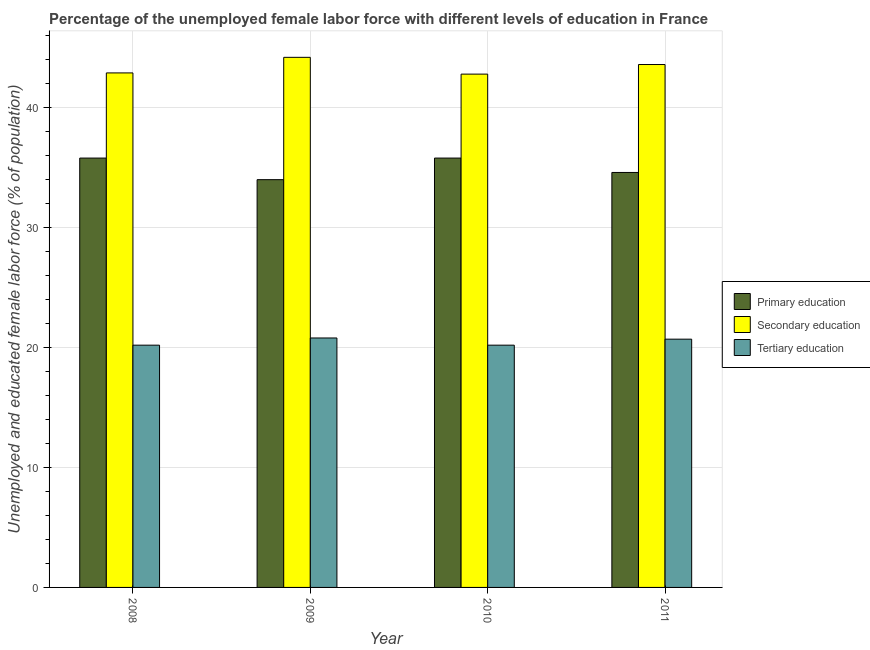How many groups of bars are there?
Keep it short and to the point. 4. Are the number of bars on each tick of the X-axis equal?
Give a very brief answer. Yes. How many bars are there on the 3rd tick from the left?
Provide a succinct answer. 3. How many bars are there on the 3rd tick from the right?
Ensure brevity in your answer.  3. What is the label of the 1st group of bars from the left?
Your answer should be compact. 2008. In how many cases, is the number of bars for a given year not equal to the number of legend labels?
Make the answer very short. 0. What is the percentage of female labor force who received secondary education in 2011?
Provide a succinct answer. 43.6. Across all years, what is the maximum percentage of female labor force who received secondary education?
Your answer should be very brief. 44.2. Across all years, what is the minimum percentage of female labor force who received secondary education?
Provide a short and direct response. 42.8. In which year was the percentage of female labor force who received primary education maximum?
Offer a very short reply. 2008. In which year was the percentage of female labor force who received primary education minimum?
Ensure brevity in your answer.  2009. What is the total percentage of female labor force who received tertiary education in the graph?
Your answer should be very brief. 81.9. What is the difference between the percentage of female labor force who received primary education in 2010 and that in 2011?
Your response must be concise. 1.2. What is the difference between the percentage of female labor force who received tertiary education in 2008 and the percentage of female labor force who received secondary education in 2009?
Make the answer very short. -0.6. What is the average percentage of female labor force who received primary education per year?
Your response must be concise. 35.05. In the year 2008, what is the difference between the percentage of female labor force who received secondary education and percentage of female labor force who received primary education?
Ensure brevity in your answer.  0. In how many years, is the percentage of female labor force who received secondary education greater than 26 %?
Ensure brevity in your answer.  4. What is the ratio of the percentage of female labor force who received primary education in 2009 to that in 2011?
Your answer should be very brief. 0.98. Is the difference between the percentage of female labor force who received tertiary education in 2008 and 2009 greater than the difference between the percentage of female labor force who received secondary education in 2008 and 2009?
Your response must be concise. No. What is the difference between the highest and the second highest percentage of female labor force who received primary education?
Make the answer very short. 0. What is the difference between the highest and the lowest percentage of female labor force who received primary education?
Your response must be concise. 1.8. What does the 3rd bar from the left in 2009 represents?
Your answer should be very brief. Tertiary education. What does the 2nd bar from the right in 2008 represents?
Ensure brevity in your answer.  Secondary education. How many bars are there?
Provide a short and direct response. 12. Are all the bars in the graph horizontal?
Keep it short and to the point. No. How many years are there in the graph?
Your response must be concise. 4. What is the difference between two consecutive major ticks on the Y-axis?
Provide a short and direct response. 10. Are the values on the major ticks of Y-axis written in scientific E-notation?
Keep it short and to the point. No. Does the graph contain any zero values?
Your response must be concise. No. Does the graph contain grids?
Provide a succinct answer. Yes. What is the title of the graph?
Your answer should be compact. Percentage of the unemployed female labor force with different levels of education in France. What is the label or title of the X-axis?
Keep it short and to the point. Year. What is the label or title of the Y-axis?
Provide a succinct answer. Unemployed and educated female labor force (% of population). What is the Unemployed and educated female labor force (% of population) in Primary education in 2008?
Your response must be concise. 35.8. What is the Unemployed and educated female labor force (% of population) in Secondary education in 2008?
Ensure brevity in your answer.  42.9. What is the Unemployed and educated female labor force (% of population) of Tertiary education in 2008?
Provide a short and direct response. 20.2. What is the Unemployed and educated female labor force (% of population) of Secondary education in 2009?
Ensure brevity in your answer.  44.2. What is the Unemployed and educated female labor force (% of population) in Tertiary education in 2009?
Give a very brief answer. 20.8. What is the Unemployed and educated female labor force (% of population) of Primary education in 2010?
Your answer should be very brief. 35.8. What is the Unemployed and educated female labor force (% of population) in Secondary education in 2010?
Your answer should be compact. 42.8. What is the Unemployed and educated female labor force (% of population) of Tertiary education in 2010?
Provide a short and direct response. 20.2. What is the Unemployed and educated female labor force (% of population) in Primary education in 2011?
Give a very brief answer. 34.6. What is the Unemployed and educated female labor force (% of population) of Secondary education in 2011?
Make the answer very short. 43.6. What is the Unemployed and educated female labor force (% of population) of Tertiary education in 2011?
Keep it short and to the point. 20.7. Across all years, what is the maximum Unemployed and educated female labor force (% of population) of Primary education?
Make the answer very short. 35.8. Across all years, what is the maximum Unemployed and educated female labor force (% of population) in Secondary education?
Offer a very short reply. 44.2. Across all years, what is the maximum Unemployed and educated female labor force (% of population) of Tertiary education?
Your response must be concise. 20.8. Across all years, what is the minimum Unemployed and educated female labor force (% of population) of Primary education?
Your response must be concise. 34. Across all years, what is the minimum Unemployed and educated female labor force (% of population) in Secondary education?
Your answer should be very brief. 42.8. Across all years, what is the minimum Unemployed and educated female labor force (% of population) of Tertiary education?
Offer a terse response. 20.2. What is the total Unemployed and educated female labor force (% of population) in Primary education in the graph?
Your answer should be compact. 140.2. What is the total Unemployed and educated female labor force (% of population) of Secondary education in the graph?
Keep it short and to the point. 173.5. What is the total Unemployed and educated female labor force (% of population) of Tertiary education in the graph?
Give a very brief answer. 81.9. What is the difference between the Unemployed and educated female labor force (% of population) of Tertiary education in 2008 and that in 2009?
Keep it short and to the point. -0.6. What is the difference between the Unemployed and educated female labor force (% of population) in Primary education in 2008 and that in 2010?
Your answer should be very brief. 0. What is the difference between the Unemployed and educated female labor force (% of population) of Tertiary education in 2008 and that in 2010?
Give a very brief answer. 0. What is the difference between the Unemployed and educated female labor force (% of population) in Secondary education in 2008 and that in 2011?
Offer a terse response. -0.7. What is the difference between the Unemployed and educated female labor force (% of population) of Secondary education in 2009 and that in 2010?
Your response must be concise. 1.4. What is the difference between the Unemployed and educated female labor force (% of population) in Secondary education in 2008 and the Unemployed and educated female labor force (% of population) in Tertiary education in 2009?
Make the answer very short. 22.1. What is the difference between the Unemployed and educated female labor force (% of population) in Primary education in 2008 and the Unemployed and educated female labor force (% of population) in Secondary education in 2010?
Ensure brevity in your answer.  -7. What is the difference between the Unemployed and educated female labor force (% of population) of Primary education in 2008 and the Unemployed and educated female labor force (% of population) of Tertiary education in 2010?
Give a very brief answer. 15.6. What is the difference between the Unemployed and educated female labor force (% of population) in Secondary education in 2008 and the Unemployed and educated female labor force (% of population) in Tertiary education in 2010?
Make the answer very short. 22.7. What is the difference between the Unemployed and educated female labor force (% of population) in Primary education in 2008 and the Unemployed and educated female labor force (% of population) in Tertiary education in 2011?
Your answer should be compact. 15.1. What is the difference between the Unemployed and educated female labor force (% of population) of Primary education in 2009 and the Unemployed and educated female labor force (% of population) of Secondary education in 2010?
Your answer should be compact. -8.8. What is the difference between the Unemployed and educated female labor force (% of population) of Primary education in 2009 and the Unemployed and educated female labor force (% of population) of Tertiary education in 2011?
Offer a very short reply. 13.3. What is the difference between the Unemployed and educated female labor force (% of population) of Secondary education in 2009 and the Unemployed and educated female labor force (% of population) of Tertiary education in 2011?
Make the answer very short. 23.5. What is the difference between the Unemployed and educated female labor force (% of population) in Secondary education in 2010 and the Unemployed and educated female labor force (% of population) in Tertiary education in 2011?
Your response must be concise. 22.1. What is the average Unemployed and educated female labor force (% of population) of Primary education per year?
Your answer should be compact. 35.05. What is the average Unemployed and educated female labor force (% of population) of Secondary education per year?
Keep it short and to the point. 43.38. What is the average Unemployed and educated female labor force (% of population) of Tertiary education per year?
Offer a very short reply. 20.48. In the year 2008, what is the difference between the Unemployed and educated female labor force (% of population) of Primary education and Unemployed and educated female labor force (% of population) of Tertiary education?
Offer a terse response. 15.6. In the year 2008, what is the difference between the Unemployed and educated female labor force (% of population) in Secondary education and Unemployed and educated female labor force (% of population) in Tertiary education?
Give a very brief answer. 22.7. In the year 2009, what is the difference between the Unemployed and educated female labor force (% of population) of Primary education and Unemployed and educated female labor force (% of population) of Tertiary education?
Ensure brevity in your answer.  13.2. In the year 2009, what is the difference between the Unemployed and educated female labor force (% of population) in Secondary education and Unemployed and educated female labor force (% of population) in Tertiary education?
Ensure brevity in your answer.  23.4. In the year 2010, what is the difference between the Unemployed and educated female labor force (% of population) in Primary education and Unemployed and educated female labor force (% of population) in Secondary education?
Provide a short and direct response. -7. In the year 2010, what is the difference between the Unemployed and educated female labor force (% of population) in Primary education and Unemployed and educated female labor force (% of population) in Tertiary education?
Your answer should be very brief. 15.6. In the year 2010, what is the difference between the Unemployed and educated female labor force (% of population) of Secondary education and Unemployed and educated female labor force (% of population) of Tertiary education?
Your answer should be compact. 22.6. In the year 2011, what is the difference between the Unemployed and educated female labor force (% of population) in Primary education and Unemployed and educated female labor force (% of population) in Secondary education?
Keep it short and to the point. -9. In the year 2011, what is the difference between the Unemployed and educated female labor force (% of population) of Primary education and Unemployed and educated female labor force (% of population) of Tertiary education?
Your answer should be very brief. 13.9. In the year 2011, what is the difference between the Unemployed and educated female labor force (% of population) of Secondary education and Unemployed and educated female labor force (% of population) of Tertiary education?
Give a very brief answer. 22.9. What is the ratio of the Unemployed and educated female labor force (% of population) in Primary education in 2008 to that in 2009?
Offer a very short reply. 1.05. What is the ratio of the Unemployed and educated female labor force (% of population) in Secondary education in 2008 to that in 2009?
Provide a succinct answer. 0.97. What is the ratio of the Unemployed and educated female labor force (% of population) of Tertiary education in 2008 to that in 2009?
Provide a succinct answer. 0.97. What is the ratio of the Unemployed and educated female labor force (% of population) in Primary education in 2008 to that in 2010?
Provide a succinct answer. 1. What is the ratio of the Unemployed and educated female labor force (% of population) of Secondary education in 2008 to that in 2010?
Provide a short and direct response. 1. What is the ratio of the Unemployed and educated female labor force (% of population) in Tertiary education in 2008 to that in 2010?
Provide a short and direct response. 1. What is the ratio of the Unemployed and educated female labor force (% of population) of Primary education in 2008 to that in 2011?
Your response must be concise. 1.03. What is the ratio of the Unemployed and educated female labor force (% of population) of Secondary education in 2008 to that in 2011?
Provide a short and direct response. 0.98. What is the ratio of the Unemployed and educated female labor force (% of population) in Tertiary education in 2008 to that in 2011?
Provide a short and direct response. 0.98. What is the ratio of the Unemployed and educated female labor force (% of population) in Primary education in 2009 to that in 2010?
Provide a succinct answer. 0.95. What is the ratio of the Unemployed and educated female labor force (% of population) of Secondary education in 2009 to that in 2010?
Ensure brevity in your answer.  1.03. What is the ratio of the Unemployed and educated female labor force (% of population) in Tertiary education in 2009 to that in 2010?
Provide a short and direct response. 1.03. What is the ratio of the Unemployed and educated female labor force (% of population) in Primary education in 2009 to that in 2011?
Give a very brief answer. 0.98. What is the ratio of the Unemployed and educated female labor force (% of population) of Secondary education in 2009 to that in 2011?
Offer a very short reply. 1.01. What is the ratio of the Unemployed and educated female labor force (% of population) in Primary education in 2010 to that in 2011?
Give a very brief answer. 1.03. What is the ratio of the Unemployed and educated female labor force (% of population) of Secondary education in 2010 to that in 2011?
Offer a very short reply. 0.98. What is the ratio of the Unemployed and educated female labor force (% of population) of Tertiary education in 2010 to that in 2011?
Provide a succinct answer. 0.98. What is the difference between the highest and the second highest Unemployed and educated female labor force (% of population) in Secondary education?
Provide a succinct answer. 0.6. What is the difference between the highest and the second highest Unemployed and educated female labor force (% of population) in Tertiary education?
Offer a very short reply. 0.1. What is the difference between the highest and the lowest Unemployed and educated female labor force (% of population) of Primary education?
Your answer should be compact. 1.8. 